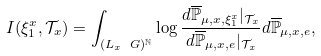Convert formula to latex. <formula><loc_0><loc_0><loc_500><loc_500>I ( \xi _ { 1 } ^ { x } , \mathcal { T } _ { x } ) = \int _ { ( L _ { x } \ G ) ^ { \mathbb { N } } } \log \frac { d \overline { \mathbb { P } } _ { \mu , x , \xi _ { 1 } ^ { x } } | _ { \mathcal { T } _ { x } } } { d \overline { \mathbb { P } } _ { \mu , x , e } | _ { \mathcal { T } _ { x } } } d \overline { \mathbb { P } } _ { \mu , x , e } ,</formula> 